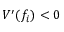<formula> <loc_0><loc_0><loc_500><loc_500>V ^ { \prime } ( f _ { i } ) < 0</formula> 